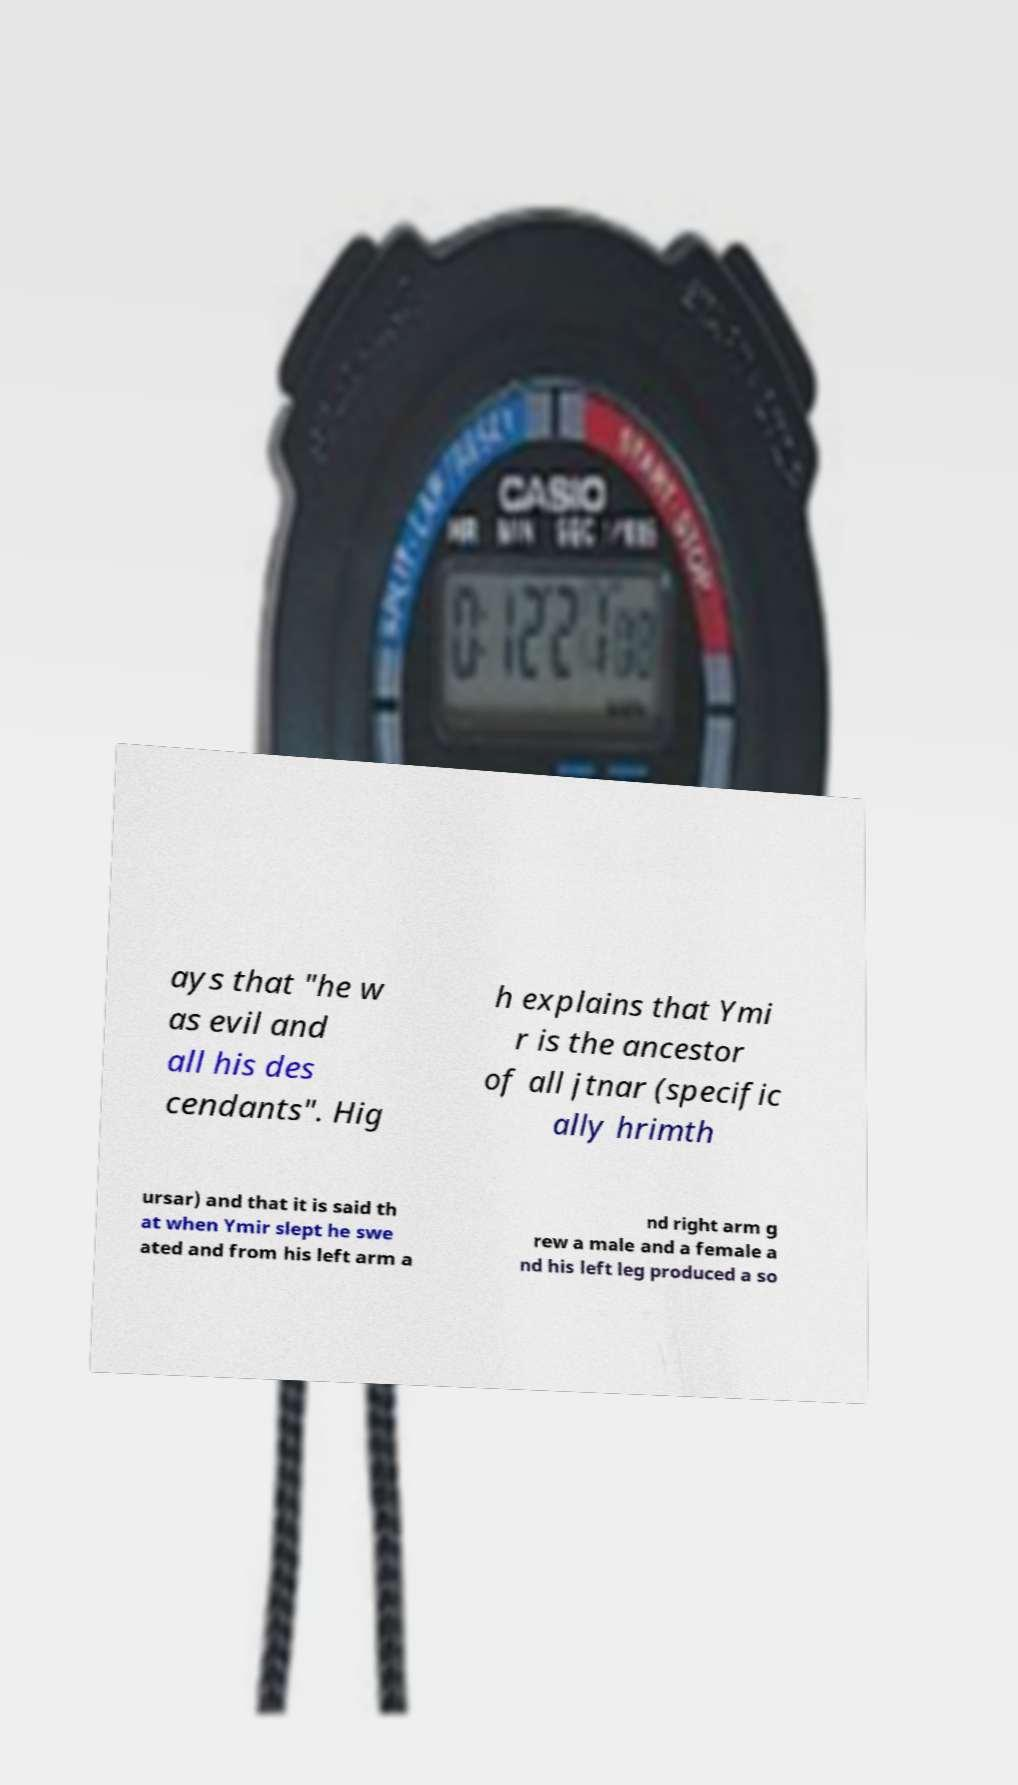Please identify and transcribe the text found in this image. ays that "he w as evil and all his des cendants". Hig h explains that Ymi r is the ancestor of all jtnar (specific ally hrimth ursar) and that it is said th at when Ymir slept he swe ated and from his left arm a nd right arm g rew a male and a female a nd his left leg produced a so 